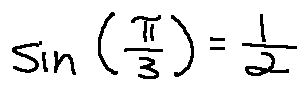Convert formula to latex. <formula><loc_0><loc_0><loc_500><loc_500>\sin ( \frac { \pi } { 3 } ) = \frac { 1 } { 2 }</formula> 